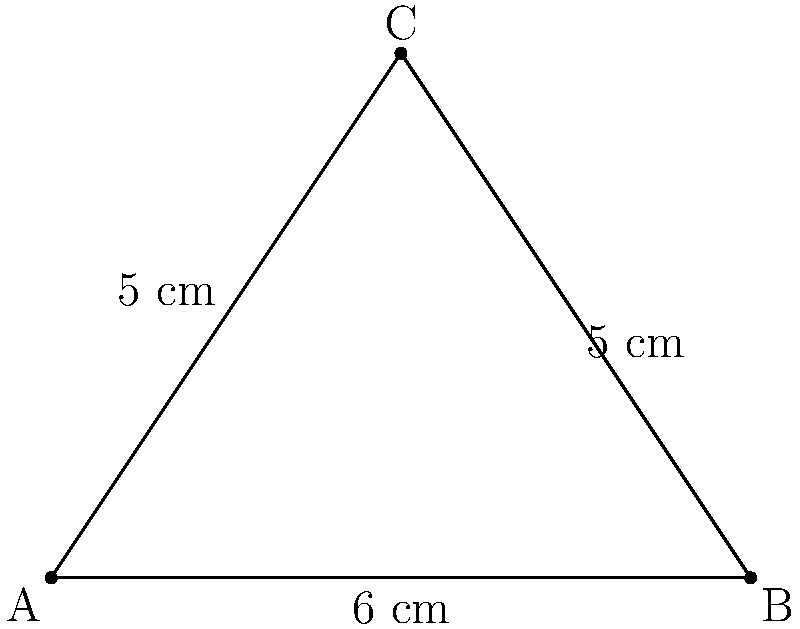As a percussionist, you're experimenting with different drumstick positions on your snare drum. Two drumsticks form a triangle with the edge of the drum, as shown in the diagram. If the distance between the sticks at the edge of the drum is 6 cm, and both sticks measure 5 cm from the edge to their intersection point, what is the angle (in degrees) between the drumsticks? Let's approach this step-by-step:

1) The triangle formed by the drumsticks and the edge of the drum is isosceles, as two sides (the drumsticks) are equal in length.

2) We can use the cosine law to find the angle. The cosine law states:
   
   $c^2 = a^2 + b^2 - 2ab \cos(C)$

   Where $C$ is the angle we're looking for, and $c$ is the side opposite to this angle.

3) In our case:
   $a = b = 5$ cm (length of drumsticks)
   $c = 6$ cm (distance between sticks at the edge)

4) Substituting into the cosine law:

   $6^2 = 5^2 + 5^2 - 2(5)(5) \cos(C)$

5) Simplify:
   
   $36 = 25 + 25 - 50 \cos(C)$
   $36 = 50 - 50 \cos(C)$

6) Solve for $\cos(C)$:

   $50 \cos(C) = 50 - 36 = 14$
   $\cos(C) = \frac{14}{50} = 0.28$

7) To get $C$, we need to take the inverse cosine (arccos):

   $C = \arccos(0.28)$

8) Calculate:
   
   $C \approx 73.74°$
Answer: $73.74°$ 